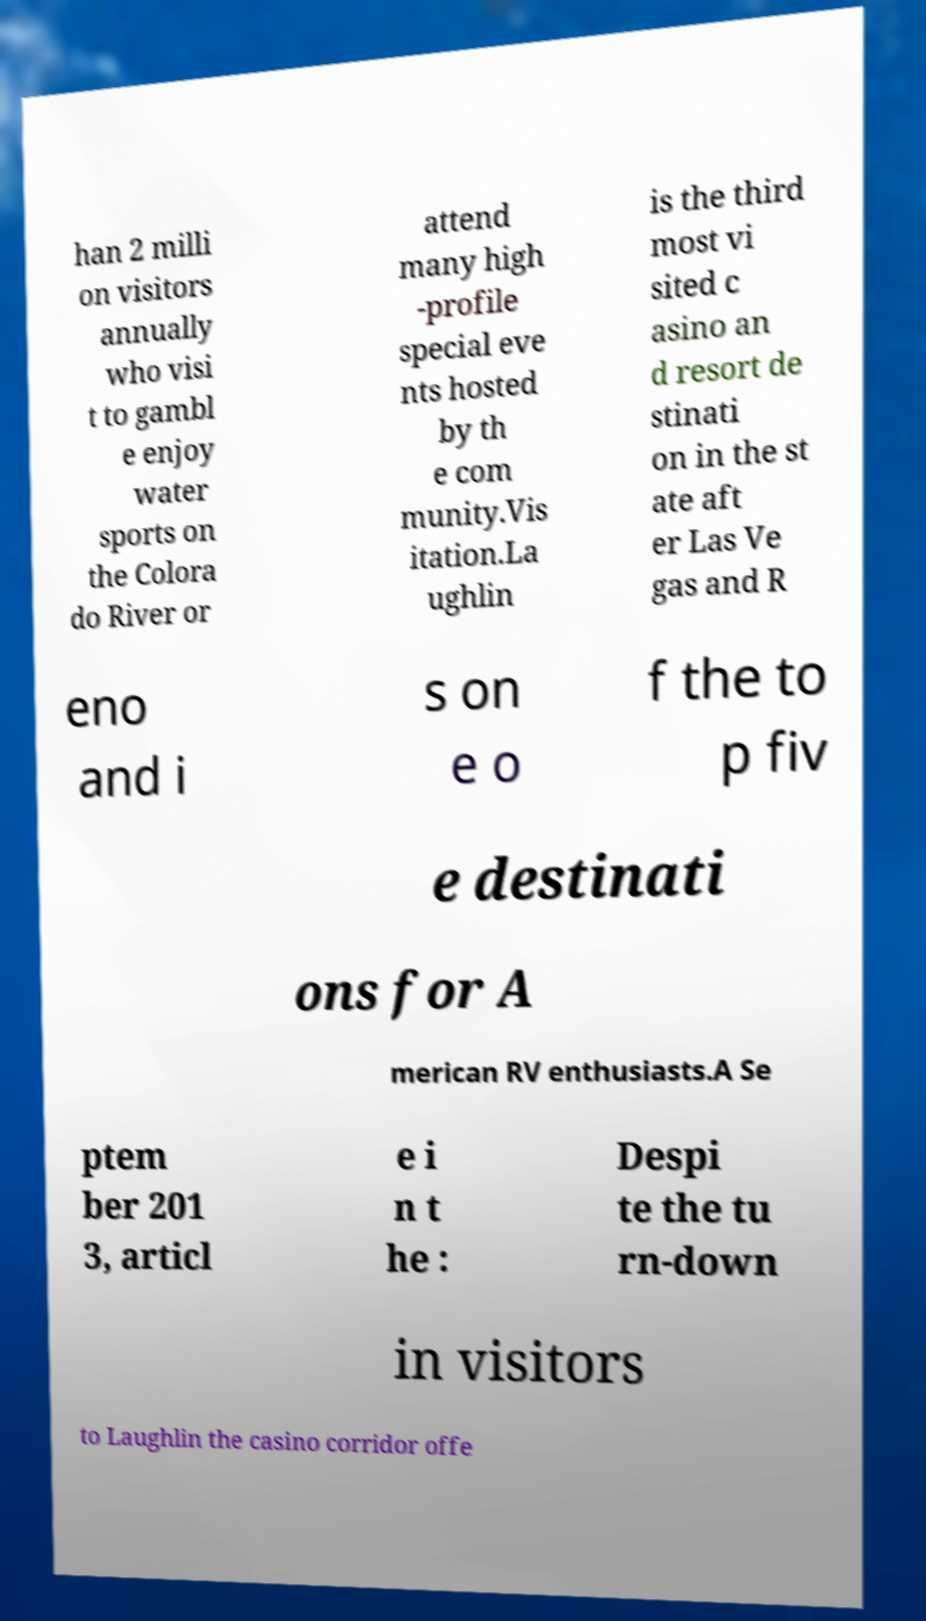Can you read and provide the text displayed in the image?This photo seems to have some interesting text. Can you extract and type it out for me? han 2 milli on visitors annually who visi t to gambl e enjoy water sports on the Colora do River or attend many high -profile special eve nts hosted by th e com munity.Vis itation.La ughlin is the third most vi sited c asino an d resort de stinati on in the st ate aft er Las Ve gas and R eno and i s on e o f the to p fiv e destinati ons for A merican RV enthusiasts.A Se ptem ber 201 3, articl e i n t he : Despi te the tu rn-down in visitors to Laughlin the casino corridor offe 